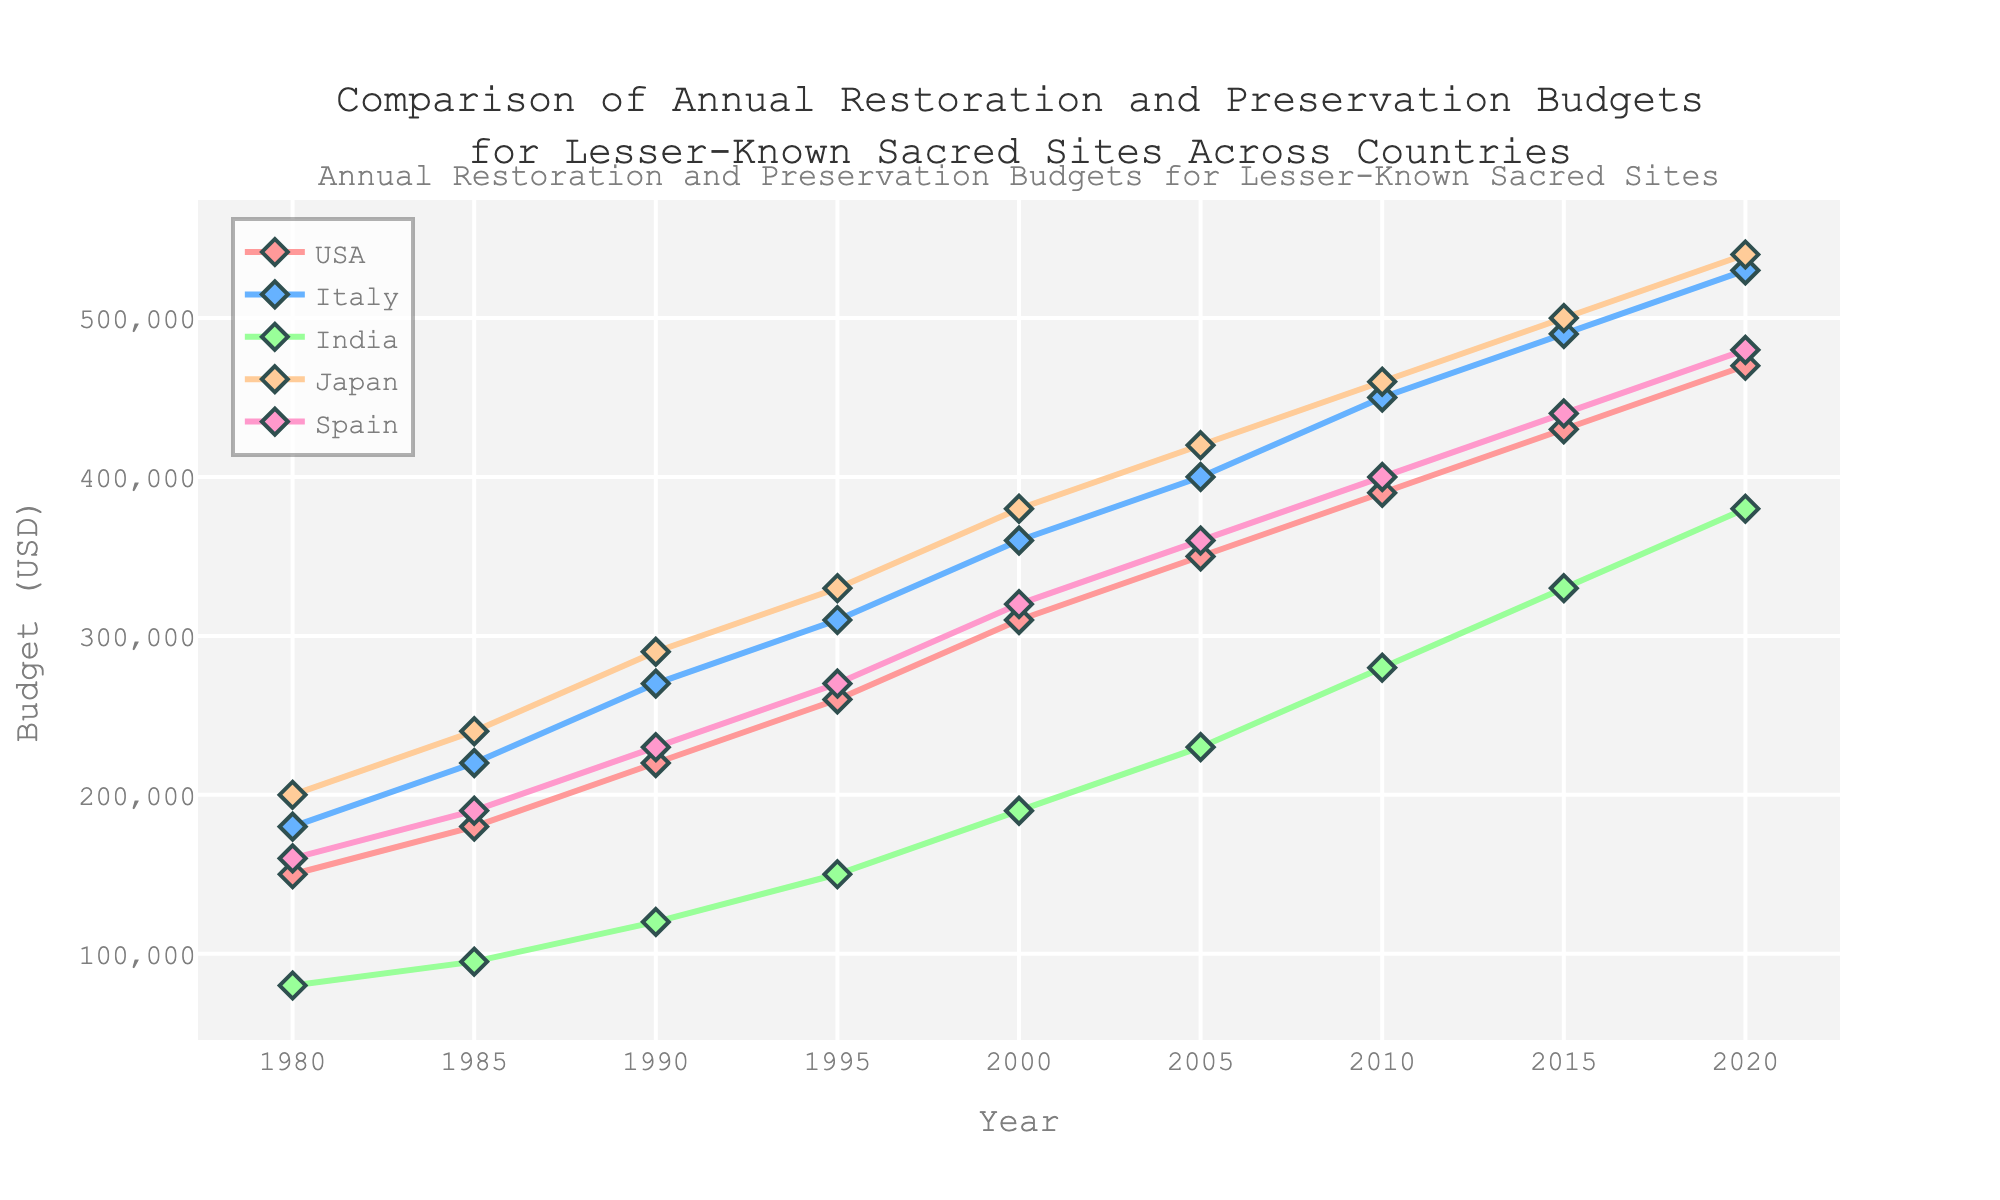Which country had the highest budget in 2020? In 2020, the country with the highest budget can be identified by looking at the endpoint of the lines in the plot. The highest endpoint in 2020 is for Japan's line.
Answer: Japan How did India's budget change from 1980 to 2020? To determine the change in India's budget, find the starting point in 1980 and the endpoint in 2020, and then find the difference. In 1980, India's budget was 80,000 USD, and in 2020, it was 380,000 USD. The change is 380,000 - 80,000 = 300,000 USD.
Answer: Increased by 300,000 USD Which two countries had the closest budgets in 1990? To find the closest budgets, compare the values for all countries in 1990. USA had 220,000 USD, Italy had 270,000 USD, India had 120,000 USD, Japan had 290,000 USD, and Spain had 230,000 USD. The closest budgets are for USA and Spain (220,000 and 230,000 respectively).
Answer: USA and Spain During which 5-year period did Japan see the highest increase in its budget? Calculate the 5-year differences for Japan's budget for each period: 1980-1985: 40,000 USD, 1985-1990: 50,000 USD, 1990-1995: 40,000 USD, 1995-2000: 50,000 USD, 2000-2005: 40,000 USD, 2005-2010: 40,000 USD, 2010-2015: 40,000 USD, 2015-2020: 40,000 USD. The highest increase was from 1985 to 1990 with a 50,000 USD increase.
Answer: 1985 to 1990 What is the average budget for Italy from 1980 to 2020? To find the average budget, sum up Italy's budget for each year and divide by the total number of years. The values are 180,000, 220,000, 270,000, 310,000, 360,000, 400,000, 450,000, 490,000, 530,000. Sum is 3,210,000. The number of years is 9. The average is 3,210,000 / 9 = 356,667 USD.
Answer: 356,667 USD Which country showed the most consistent increase in its budget over the years? A consistent increase means the budget rose steadily without large fluctuations in growth from period to period. By examining the slopes of the lines, Japan's budget line shows the most consistent, steady increase without large deviations.
Answer: Japan What was the total budget for all countries combined in 2005? To find the total, sum the budgets for all countries in 2005. USA: 350,000 USD, Italy: 400,000 USD, India: 230,000 USD, Japan: 420,000 USD, Spain: 360,000 USD. Total is 1,760,000 USD.
Answer: 1,760,000 USD Compare the budget growth from 2000 to 2020 for Spain and USA. Which country had a higher absolute increase? Calculate the budget increase for each country. Spain: 480,000 - 320,000 = 160,000 USD. USA: 470,000 - 310,000 = 160,000 USD. Both countries had the same absolute increase of 160,000 USD.
Answer: Both same What is the median budget for Japan over the years? To find the median, list Japan's budgets in ascending order and find the middle value. The values are 200,000, 240,000, 290,000, 330,000, 380,000, 420,000, 460,000, 500,000, 540,000. The median (middle value of the sorted list) is 380,000 USD.
Answer: 380,000 USD 